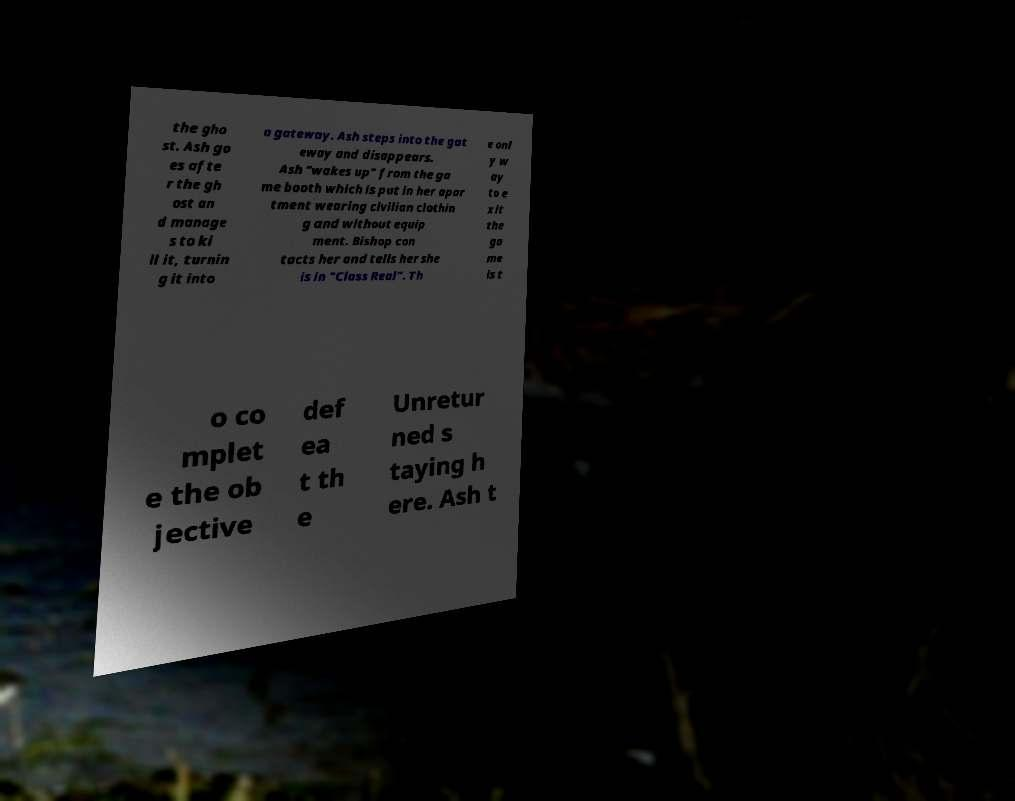Can you accurately transcribe the text from the provided image for me? the gho st. Ash go es afte r the gh ost an d manage s to ki ll it, turnin g it into a gateway. Ash steps into the gat eway and disappears. Ash "wakes up" from the ga me booth which is put in her apar tment wearing civilian clothin g and without equip ment. Bishop con tacts her and tells her she is in "Class Real". Th e onl y w ay to e xit the ga me is t o co mplet e the ob jective def ea t th e Unretur ned s taying h ere. Ash t 